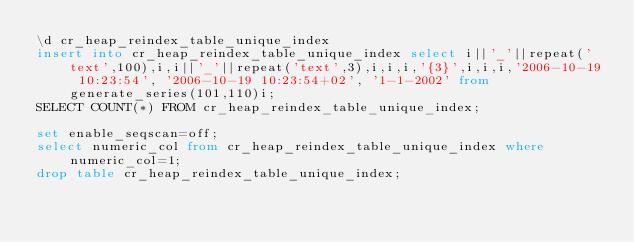<code> <loc_0><loc_0><loc_500><loc_500><_SQL_>\d cr_heap_reindex_table_unique_index
insert into cr_heap_reindex_table_unique_index select i||'_'||repeat('text',100),i,i||'_'||repeat('text',3),i,i,i,'{3}',i,i,i,'2006-10-19 10:23:54', '2006-10-19 10:23:54+02', '1-1-2002' from generate_series(101,110)i;
SELECT COUNT(*) FROM cr_heap_reindex_table_unique_index;

set enable_seqscan=off;
select numeric_col from cr_heap_reindex_table_unique_index where numeric_col=1;
drop table cr_heap_reindex_table_unique_index;
</code> 